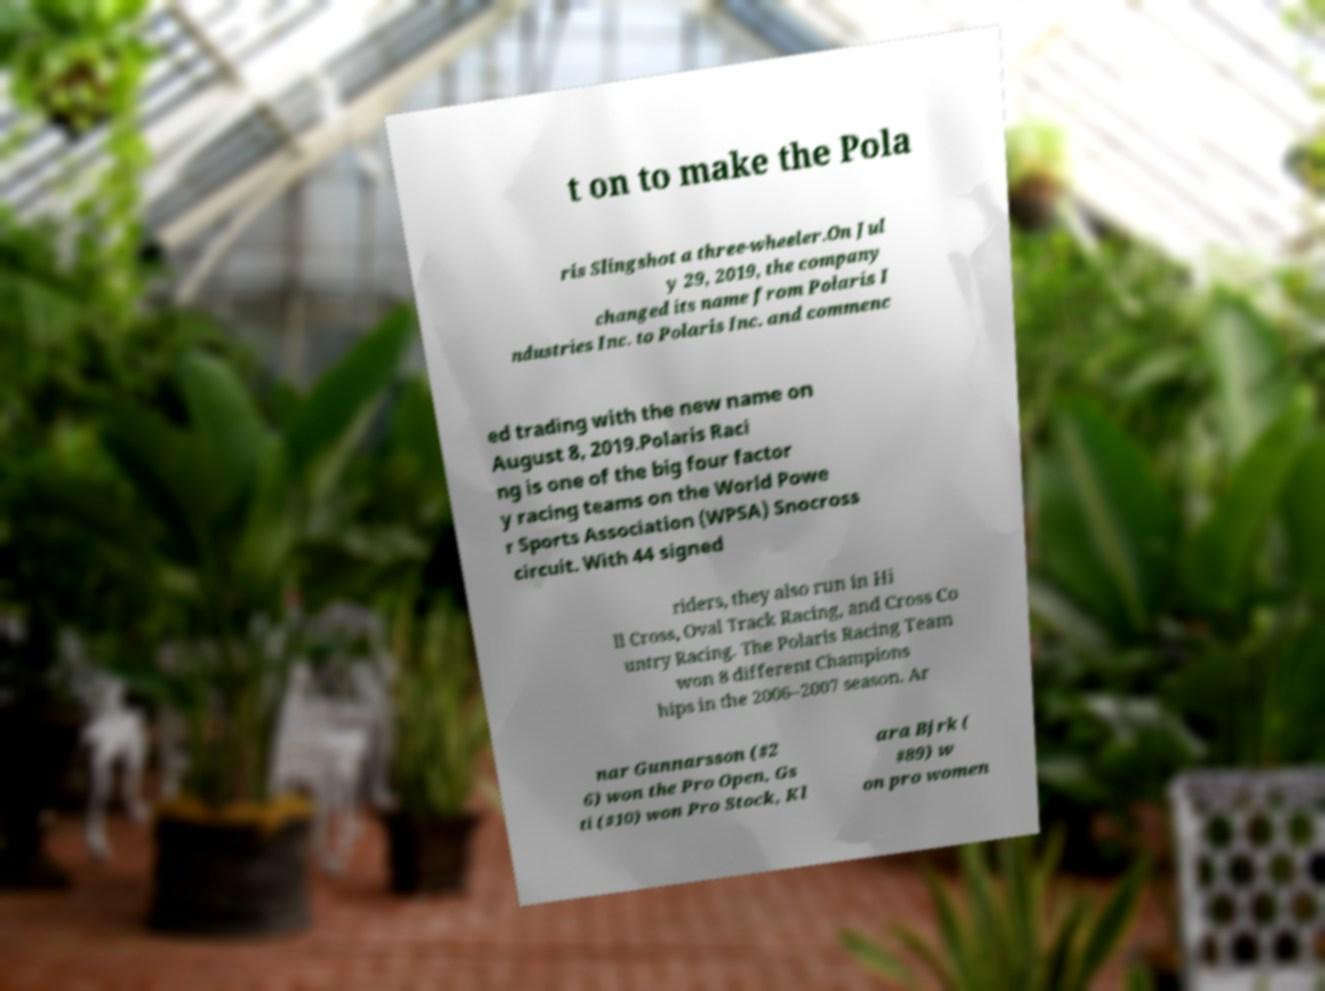Please read and relay the text visible in this image. What does it say? t on to make the Pola ris Slingshot a three-wheeler.On Jul y 29, 2019, the company changed its name from Polaris I ndustries Inc. to Polaris Inc. and commenc ed trading with the new name on August 8, 2019.Polaris Raci ng is one of the big four factor y racing teams on the World Powe r Sports Association (WPSA) Snocross circuit. With 44 signed riders, they also run in Hi ll Cross, Oval Track Racing, and Cross Co untry Racing. The Polaris Racing Team won 8 different Champions hips in the 2006–2007 season. Ar nar Gunnarsson (#2 6) won the Pro Open, Gs ti (#10) won Pro Stock, Kl ara Bjrk ( #89) w on pro women 